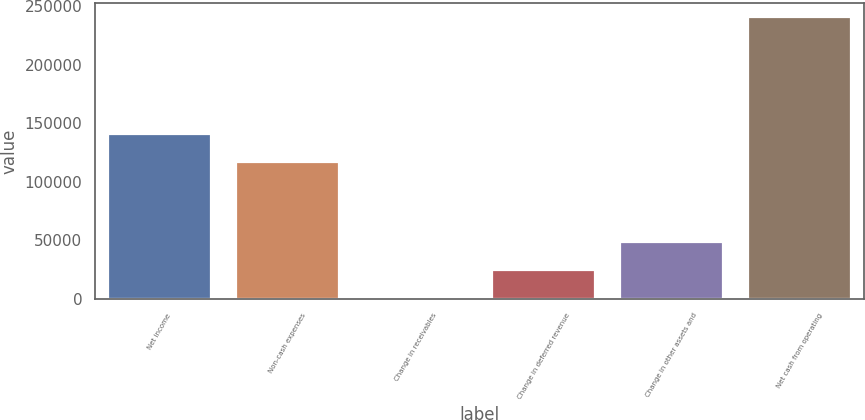<chart> <loc_0><loc_0><loc_500><loc_500><bar_chart><fcel>Net income<fcel>Non-cash expenses<fcel>Change in receivables<fcel>Change in deferred revenue<fcel>Change in other assets and<fcel>Net cash from operating<nl><fcel>140707<fcel>116788<fcel>940<fcel>24859.2<fcel>48778.4<fcel>240132<nl></chart> 